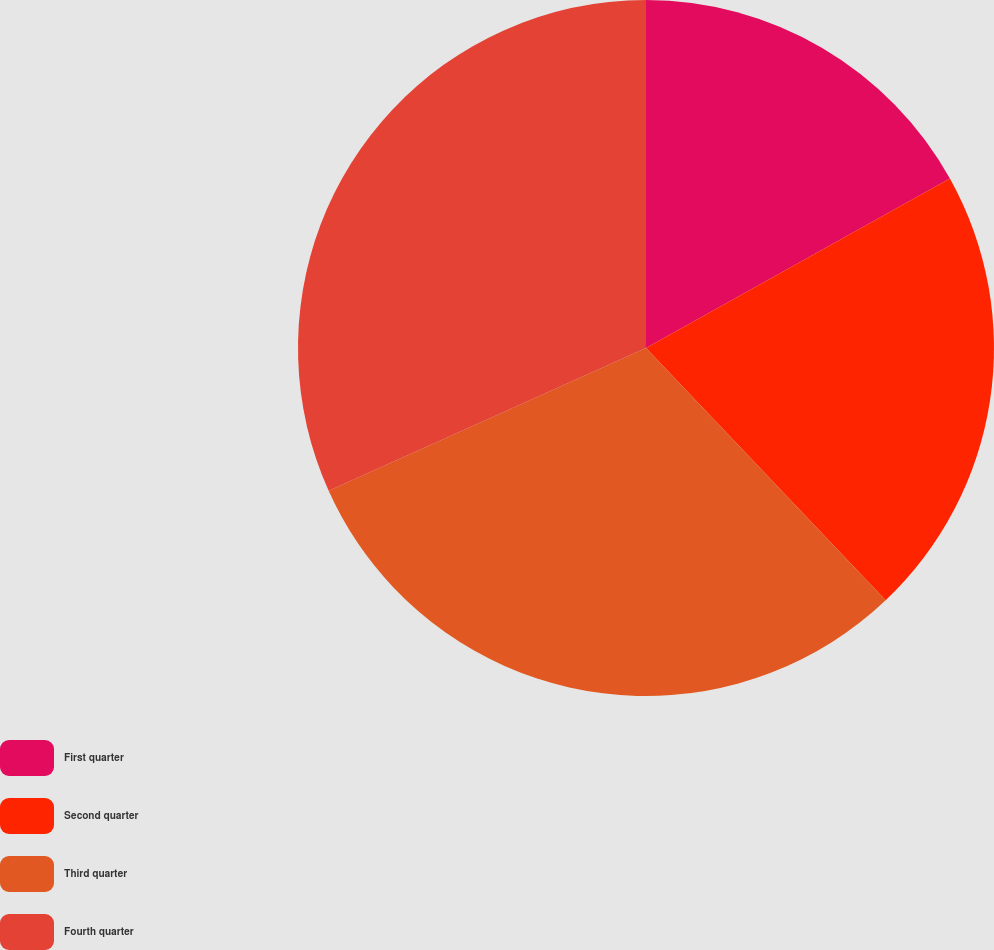Convert chart. <chart><loc_0><loc_0><loc_500><loc_500><pie_chart><fcel>First quarter<fcel>Second quarter<fcel>Third quarter<fcel>Fourth quarter<nl><fcel>16.9%<fcel>21.01%<fcel>30.36%<fcel>31.73%<nl></chart> 